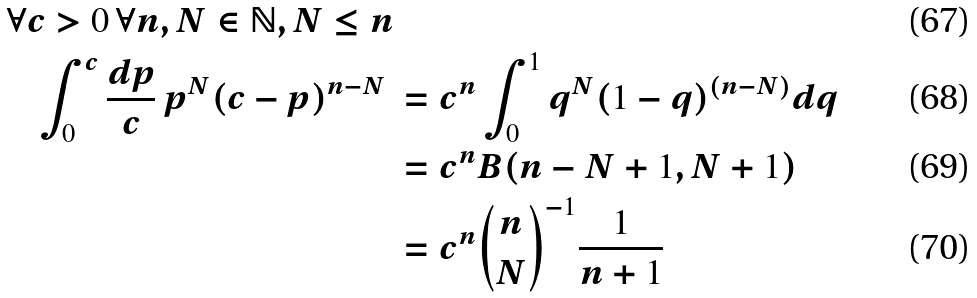Convert formula to latex. <formula><loc_0><loc_0><loc_500><loc_500>\forall c > 0 \, \forall n , N \in \mathbb { N } , N \leq n \\ \int _ { 0 } ^ { c } \frac { d p } { c } \, p ^ { N } ( c - p ) ^ { n - N } \ & = c ^ { n } \int _ { 0 } ^ { 1 } q ^ { N } ( 1 - q ) ^ { ( n - N ) } d q \\ & = c ^ { n } B ( n - N + 1 , N + 1 ) \\ & = c ^ { n } { n \choose N } ^ { - 1 } \frac { 1 } { n + 1 }</formula> 